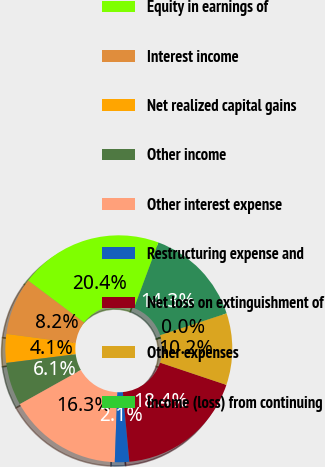Convert chart. <chart><loc_0><loc_0><loc_500><loc_500><pie_chart><fcel>Years Ended December 31 (in<fcel>Equity in earnings of<fcel>Interest income<fcel>Net realized capital gains<fcel>Other income<fcel>Other interest expense<fcel>Restructuring expense and<fcel>Net loss on extinguishment of<fcel>Other expenses<fcel>Income (loss) from continuing<nl><fcel>14.28%<fcel>20.4%<fcel>8.16%<fcel>4.09%<fcel>6.12%<fcel>16.32%<fcel>2.05%<fcel>18.36%<fcel>10.2%<fcel>0.01%<nl></chart> 